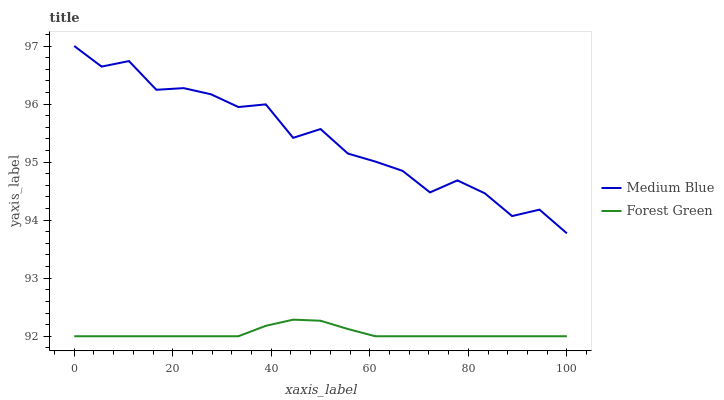Does Forest Green have the minimum area under the curve?
Answer yes or no. Yes. Does Medium Blue have the maximum area under the curve?
Answer yes or no. Yes. Does Medium Blue have the minimum area under the curve?
Answer yes or no. No. Is Forest Green the smoothest?
Answer yes or no. Yes. Is Medium Blue the roughest?
Answer yes or no. Yes. Is Medium Blue the smoothest?
Answer yes or no. No. Does Medium Blue have the lowest value?
Answer yes or no. No. Does Medium Blue have the highest value?
Answer yes or no. Yes. Is Forest Green less than Medium Blue?
Answer yes or no. Yes. Is Medium Blue greater than Forest Green?
Answer yes or no. Yes. Does Forest Green intersect Medium Blue?
Answer yes or no. No. 